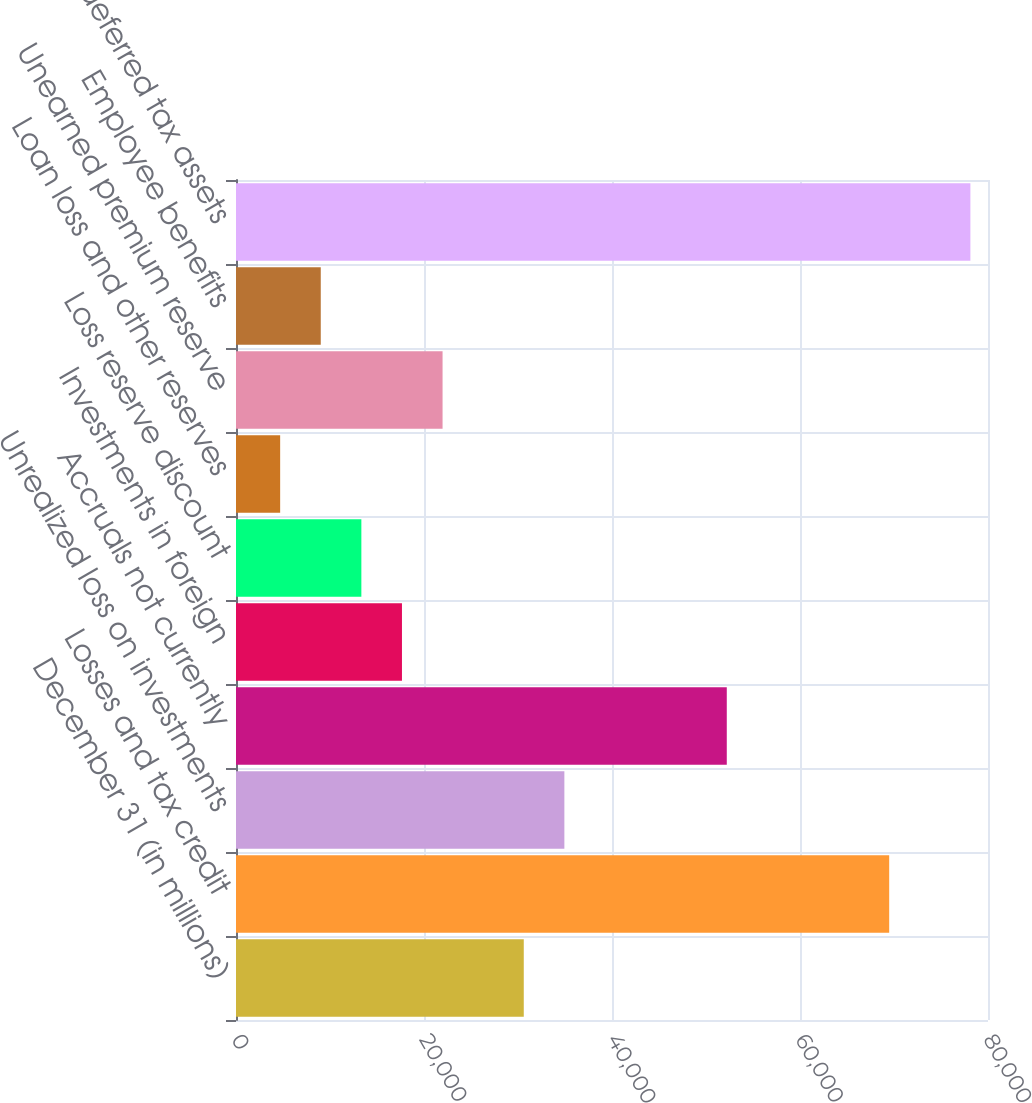<chart> <loc_0><loc_0><loc_500><loc_500><bar_chart><fcel>December 31 (in millions)<fcel>Losses and tax credit<fcel>Unrealized loss on investments<fcel>Accruals not currently<fcel>Investments in foreign<fcel>Loss reserve discount<fcel>Loan loss and other reserves<fcel>Unearned premium reserve<fcel>Employee benefits<fcel>Total deferred tax assets<nl><fcel>30613.8<fcel>69488.4<fcel>34933.2<fcel>52210.8<fcel>17655.6<fcel>13336.2<fcel>4697.4<fcel>21975<fcel>9016.8<fcel>78127.2<nl></chart> 